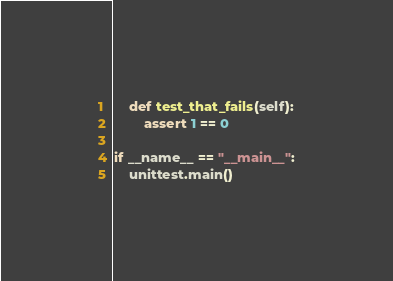<code> <loc_0><loc_0><loc_500><loc_500><_Python_>
    def test_that_fails(self):
        assert 1 == 0

if __name__ == "__main__":
    unittest.main()
</code> 